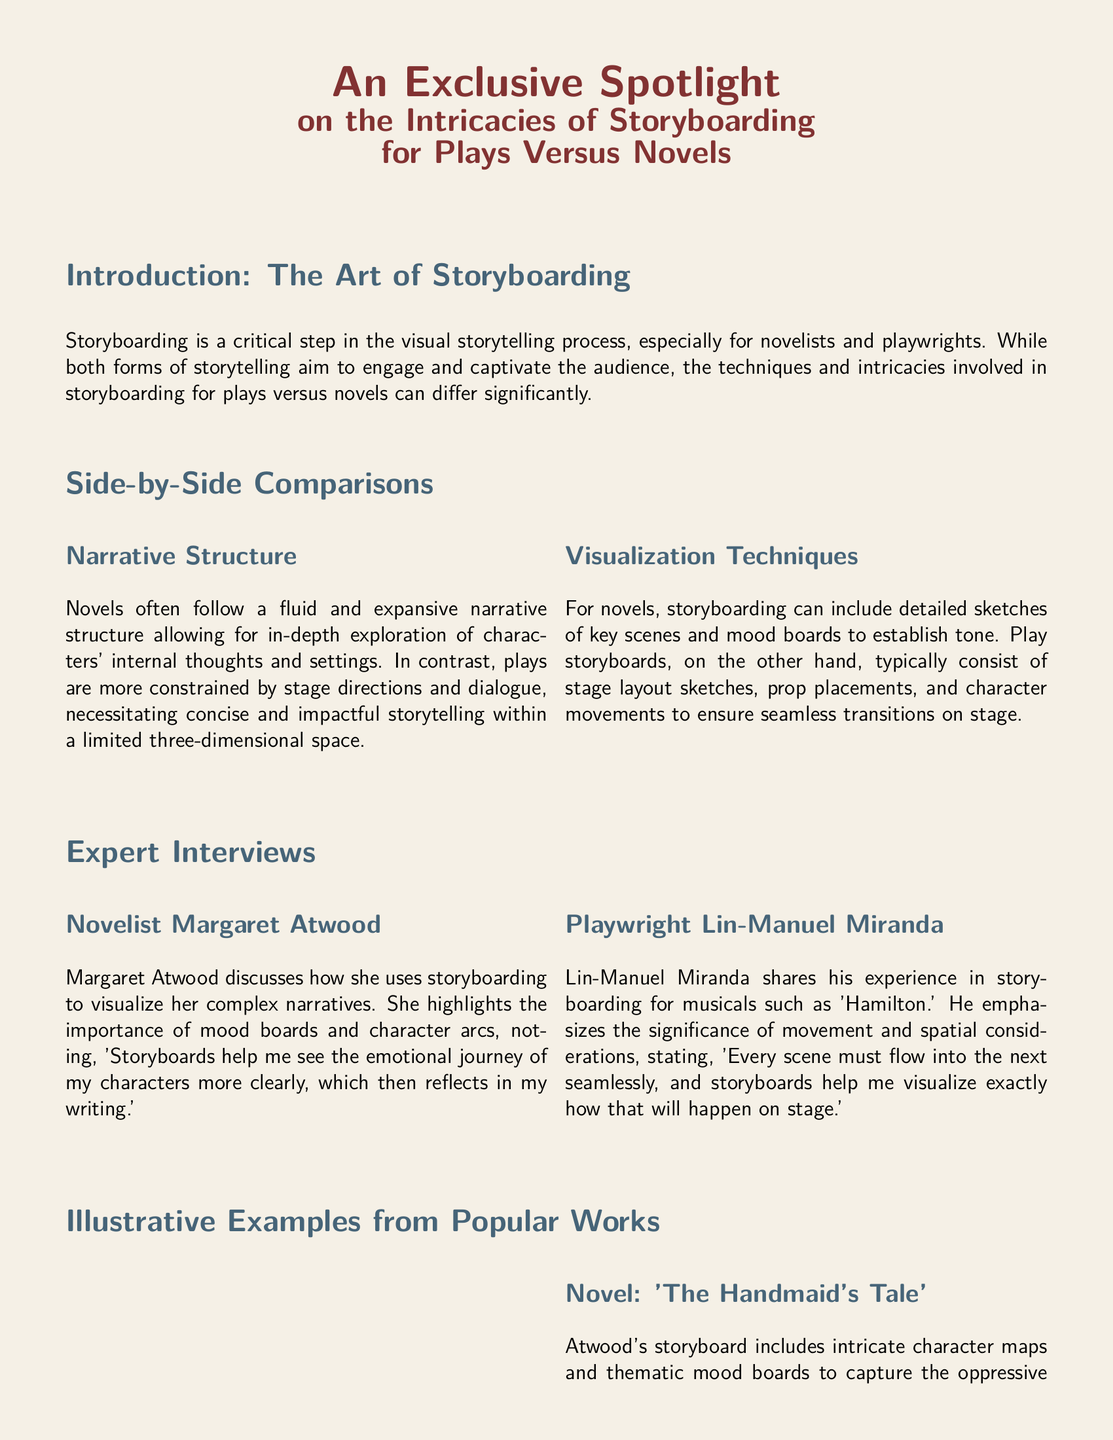What is the focus of the document? The document highlights the differences and intricacies of storyboarding for plays versus novels in visual storytelling.
Answer: storyboarding for plays versus novels Who is the novelist interviewed in the document? The interview features well-known authors discussing their storyboarding processes.
Answer: Margaret Atwood What is the title of the play discussed by Lin-Manuel Miranda? The document references a specific play that showcases the importance of storyboarding for performance.
Answer: Hamilton What type of narrative structure do novels typically follow? The document describes the narrative structure that gives novels their depth in character exploration and storytelling.
Answer: fluid and expansive What visual element is emphasized in Lin-Manuel Miranda's storyboarding? The document mentions key aspects of stage management in the context of storyboarding for plays.
Answer: movement and spatial considerations What key feature differentiates play storyboards from novel storyboards? The document outlines distinct visual components necessary for each storytelling medium.
Answer: stage layout sketches Which novel's storyboard includes character maps? The document provides an example of a novel that utilizes detailed character visualization techniques in its storyboarding.
Answer: The Handmaid's Tale What did Margaret Atwood say about storyboards? The document features a quote that reflects the importance of visualization in her writing process.
Answer: emotional journey of my characters 